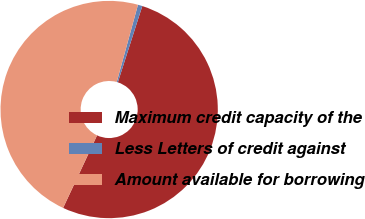<chart> <loc_0><loc_0><loc_500><loc_500><pie_chart><fcel>Maximum credit capacity of the<fcel>Less Letters of credit against<fcel>Amount available for borrowing<nl><fcel>52.04%<fcel>0.66%<fcel>47.31%<nl></chart> 